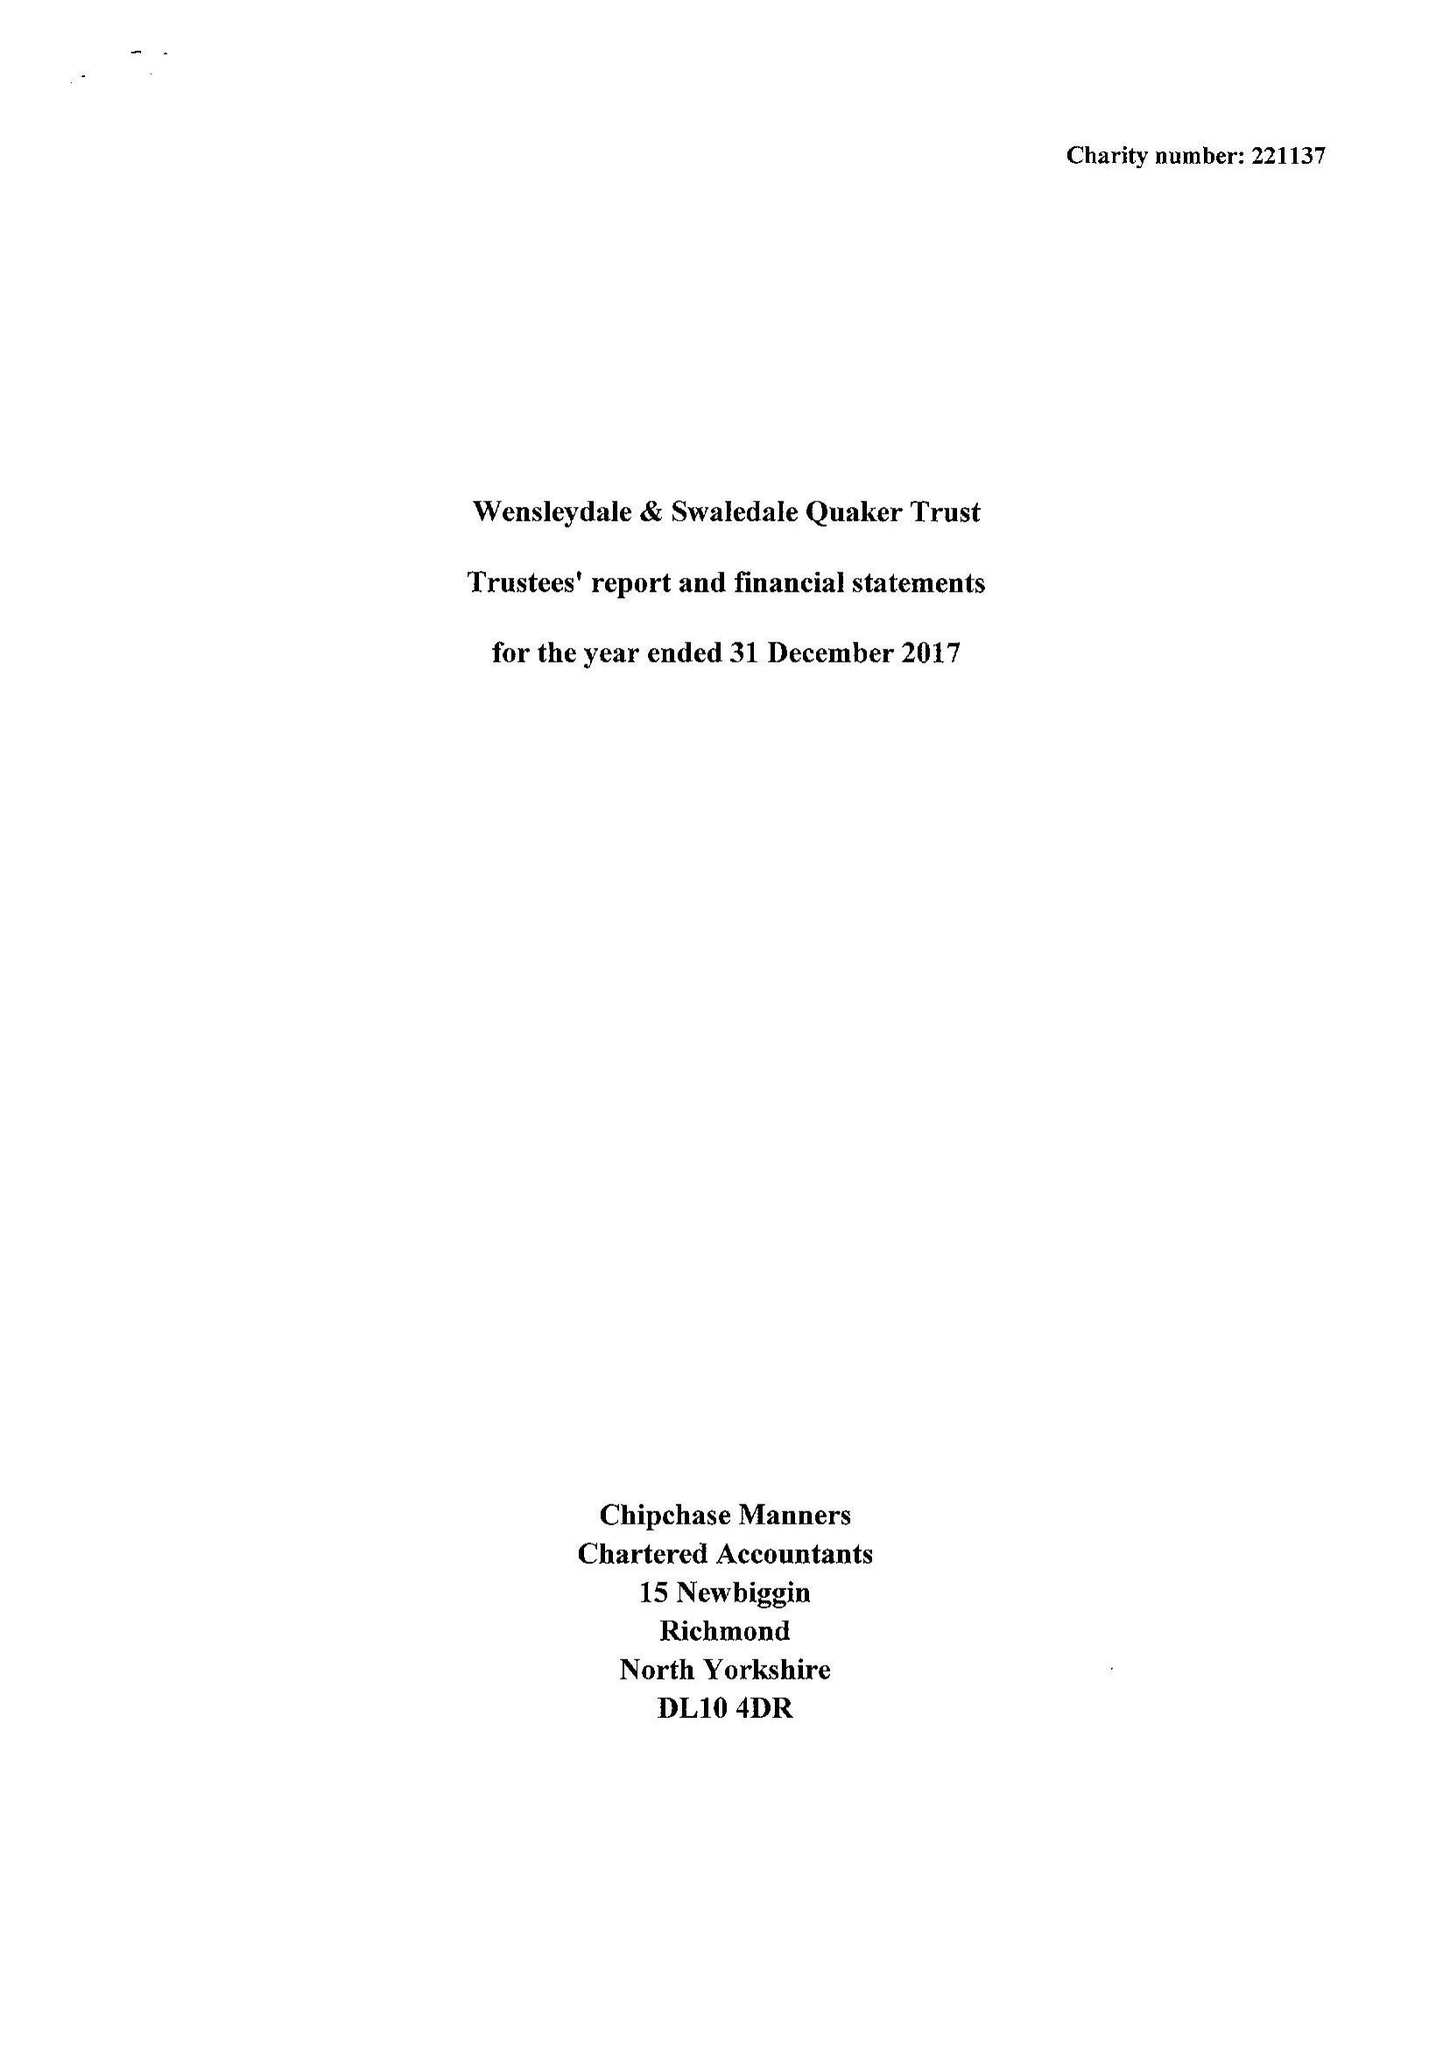What is the value for the address__street_line?
Answer the question using a single word or phrase. 7 GROVE SQUARE 